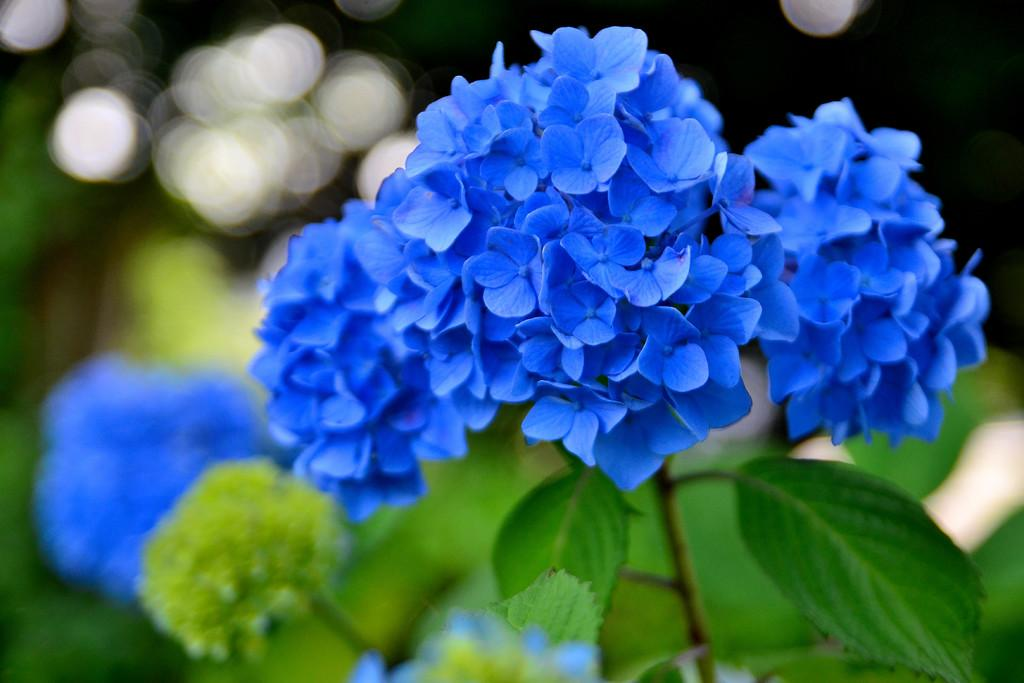What color are the flowers in the image? The flowers in the image are blue. What part of the plant do the flowers belong to? The flowers belong to a plant. What color are the leaves of the plant? The leaves of the plant are green. Can you describe the background of the image? The background of the image is blurred. How many answers can be found in the image? There are no answers present in the image, as it is a photograph of flowers and a plant. 